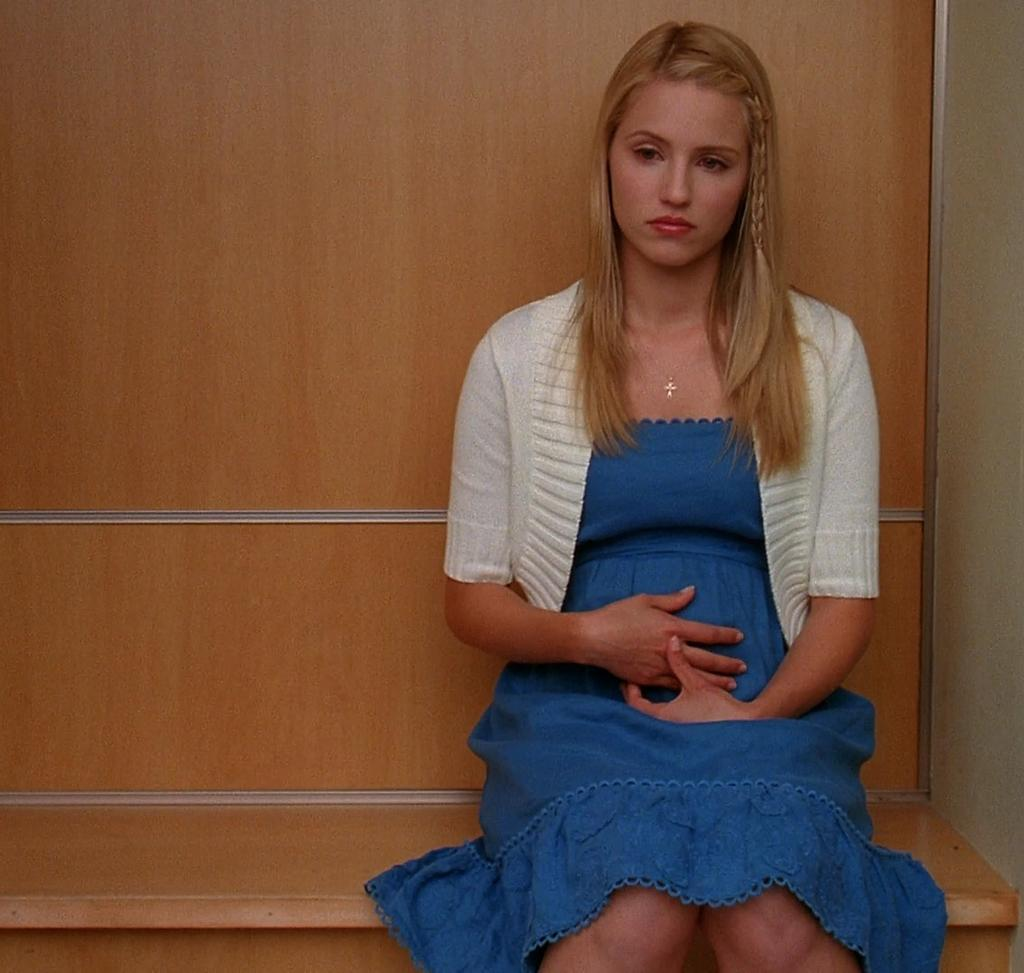Who is present in the image? There is a woman in the image. What is the woman sitting on? The woman is sitting on a wooden bench. What is the woman wearing? The woman is wearing a blue dress and a white jacket. What is the color of the woman's hair? The woman has golden hair. What can be seen in the background of the image? There is a wooden wall in the background of the image. What type of scent can be detected from the woman's clothing in the image? There is no information about the scent of the woman's clothing in the image. Can you see a toad sitting next to the woman on the bench? There is no toad present in the image. 